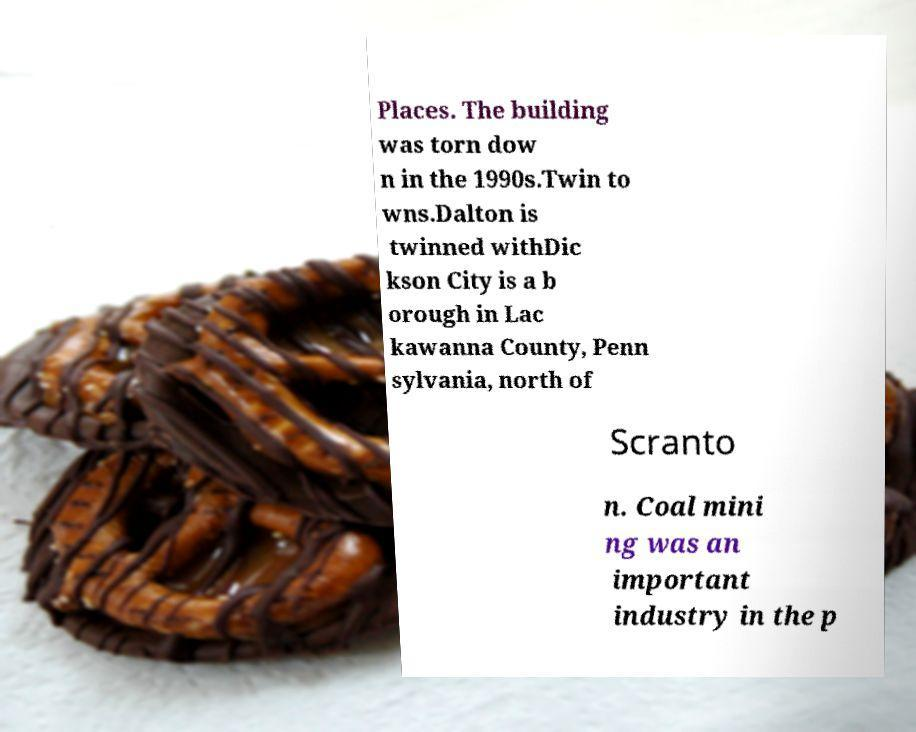Can you accurately transcribe the text from the provided image for me? Places. The building was torn dow n in the 1990s.Twin to wns.Dalton is twinned withDic kson City is a b orough in Lac kawanna County, Penn sylvania, north of Scranto n. Coal mini ng was an important industry in the p 